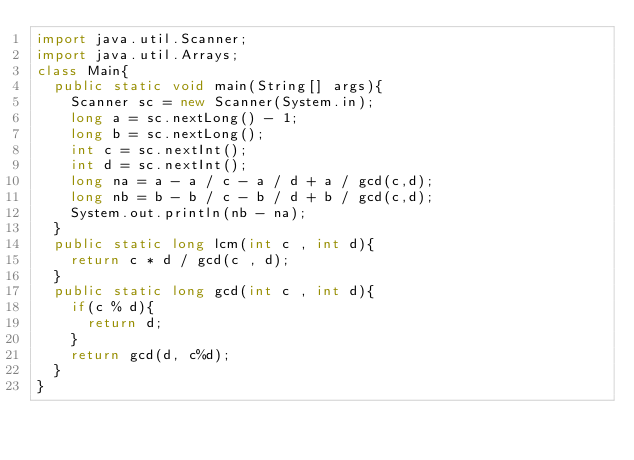<code> <loc_0><loc_0><loc_500><loc_500><_Java_>import java.util.Scanner;
import java.util.Arrays;
class Main{
  public static void main(String[] args){
    Scanner sc = new Scanner(System.in);
    long a = sc.nextLong() - 1;
    long b = sc.nextLong();
    int c = sc.nextInt();
    int d = sc.nextInt();
    long na = a - a / c - a / d + a / gcd(c,d);
    long nb = b - b / c - b / d + b / gcd(c,d);
    System.out.println(nb - na);
  }
  public static long lcm(int c , int d){
    return c * d / gcd(c , d);
  }
  public static long gcd(int c , int d){
    if(c % d){
      return d;
    }
    return gcd(d, c%d);
  }
}


</code> 